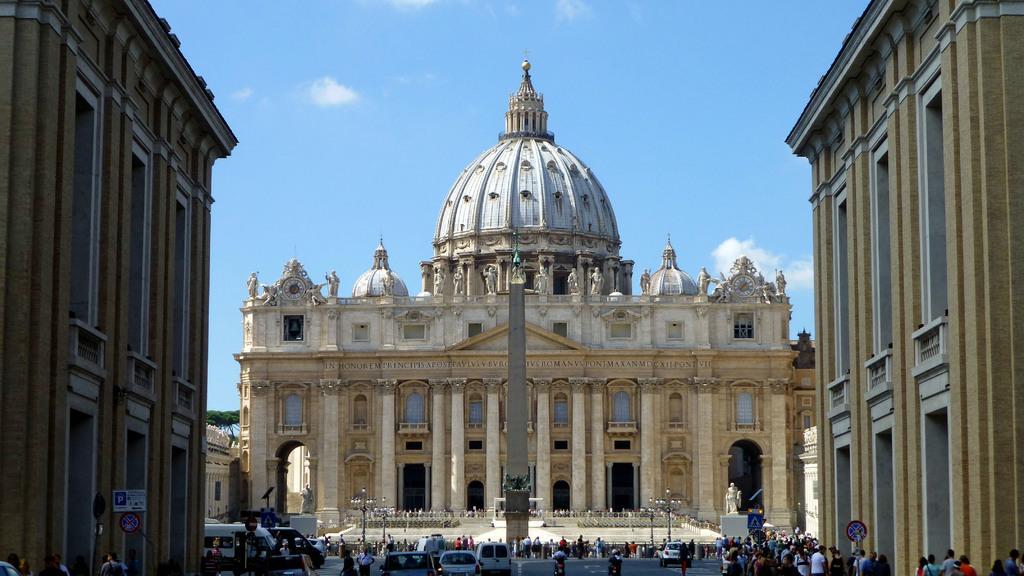How would you summarize this image in a sentence or two? In this picture I can see there are some buildings here and there is a street here and there are some vehicles on the street and there are some people walking on the street and in the backdrop there are some trees and the sky is clear. 